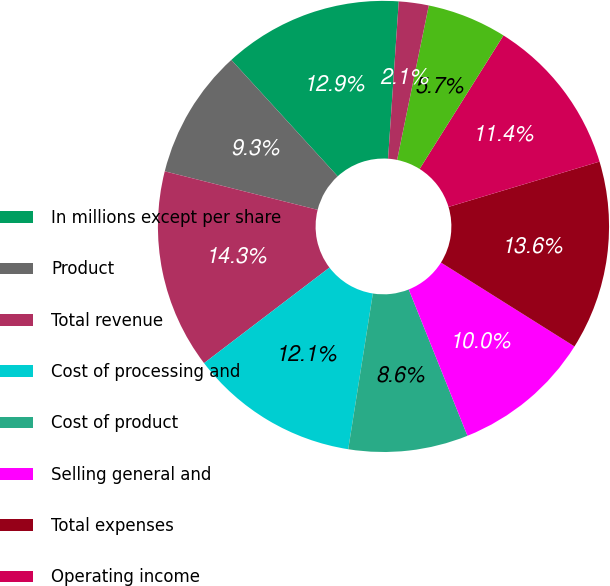Convert chart. <chart><loc_0><loc_0><loc_500><loc_500><pie_chart><fcel>In millions except per share<fcel>Product<fcel>Total revenue<fcel>Cost of processing and<fcel>Cost of product<fcel>Selling general and<fcel>Total expenses<fcel>Operating income<fcel>Interest expense<fcel>Interest and investment income<nl><fcel>12.86%<fcel>9.29%<fcel>14.29%<fcel>12.14%<fcel>8.57%<fcel>10.0%<fcel>13.57%<fcel>11.43%<fcel>5.71%<fcel>2.14%<nl></chart> 